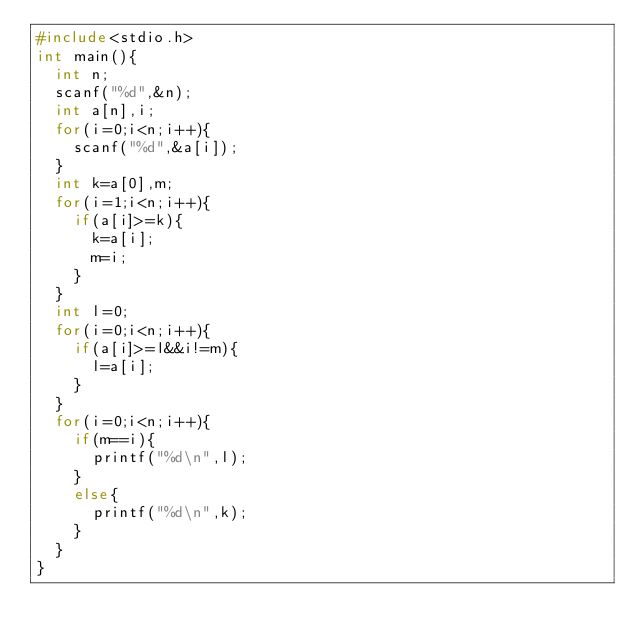Convert code to text. <code><loc_0><loc_0><loc_500><loc_500><_C++_>#include<stdio.h>
int main(){
  int n;
  scanf("%d",&n);
  int a[n],i;
  for(i=0;i<n;i++){
    scanf("%d",&a[i]);
  }
  int k=a[0],m;
  for(i=1;i<n;i++){
    if(a[i]>=k){
      k=a[i];
      m=i;
    }
  }
  int l=0;
  for(i=0;i<n;i++){
    if(a[i]>=l&&i!=m){
      l=a[i];
    }
  }
  for(i=0;i<n;i++){
    if(m==i){
      printf("%d\n",l);
    }
    else{
      printf("%d\n",k);
    }
  }
}
</code> 